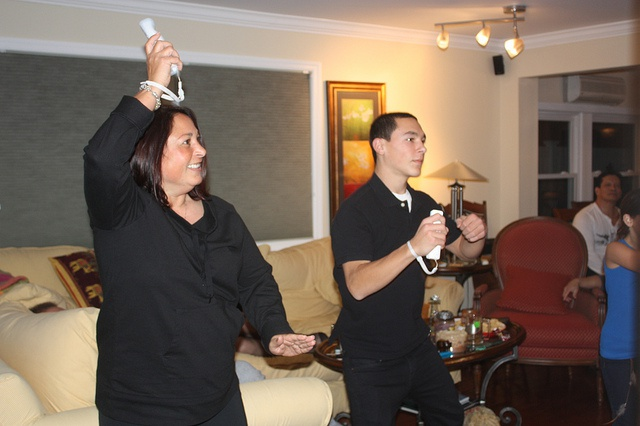Describe the objects in this image and their specific colors. I can see people in darkgray, black, tan, and maroon tones, couch in darkgray, tan, and gray tones, people in darkgray, black, tan, and gray tones, chair in darkgray, maroon, black, gray, and brown tones, and people in darkgray, black, blue, darkblue, and brown tones in this image. 